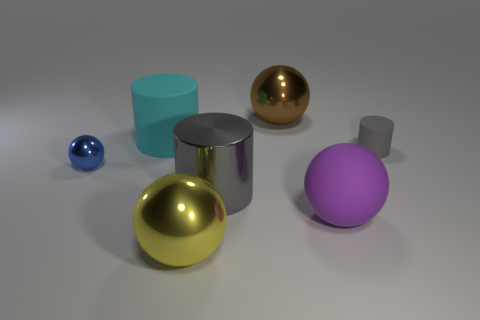How many large spheres are the same color as the small metallic object?
Offer a terse response. 0. How many tiny objects are either rubber balls or cyan cylinders?
Ensure brevity in your answer.  0. Is the tiny object to the right of the large purple matte thing made of the same material as the large purple ball?
Ensure brevity in your answer.  Yes. There is a big cylinder behind the small gray matte cylinder; what color is it?
Your answer should be very brief. Cyan. Is there a cyan rubber thing of the same size as the brown thing?
Your response must be concise. Yes. What material is the brown sphere that is the same size as the purple object?
Give a very brief answer. Metal. Does the blue metal object have the same size as the metallic sphere that is behind the large rubber cylinder?
Offer a very short reply. No. What is the material of the gray cylinder behind the tiny blue metallic object?
Provide a short and direct response. Rubber. Is the number of tiny rubber things on the right side of the small matte cylinder the same as the number of large cyan rubber spheres?
Your response must be concise. Yes. Do the brown ball and the gray metal cylinder have the same size?
Your answer should be very brief. Yes. 